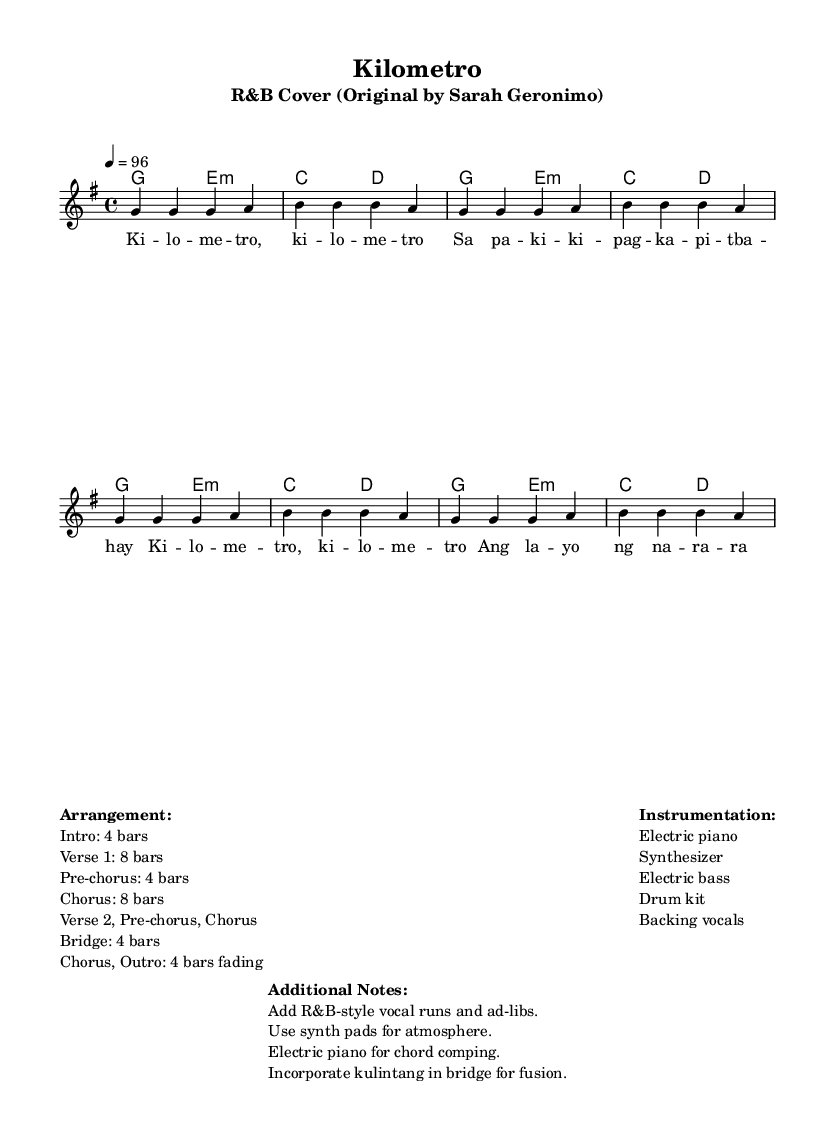What is the key signature of this music? The key signature is indicated as G major, which has one sharp (F#).
Answer: G major What is the time signature? The time signature is noted explicitly in the sheet music as 4/4, meaning there are four beats in a measure.
Answer: 4/4 What is the tempo marking? The tempo marking shown in the music is "4 = 96," indicating that there are 96 beats per minute, with each quarter note getting one beat.
Answer: 96 How many bars are in the Chorus section? The Chorus section is specified to have 8 bars according to the arrangement indicated in the markup.
Answer: 8 bars What instruments are used in this R&B arrangement? The instrumentation listed includes electric piano, synthesizer, electric bass, drum kit, and backing vocals.
Answer: Electric piano, synthesizer, electric bass, drum kit, backing vocals What unique element is incorporated in the bridge for a fusion? The bridge section incorporates a kulintang, which adds a cultural fusion element to the arrangement.
Answer: Kulintang What vocal techniques are suggested for this arrangement? The additional notes suggest adding R&B-style vocal runs and ad-libs, which are vocal embellishments characteristic of the genre.
Answer: R&B-style vocal runs and ad-libs 